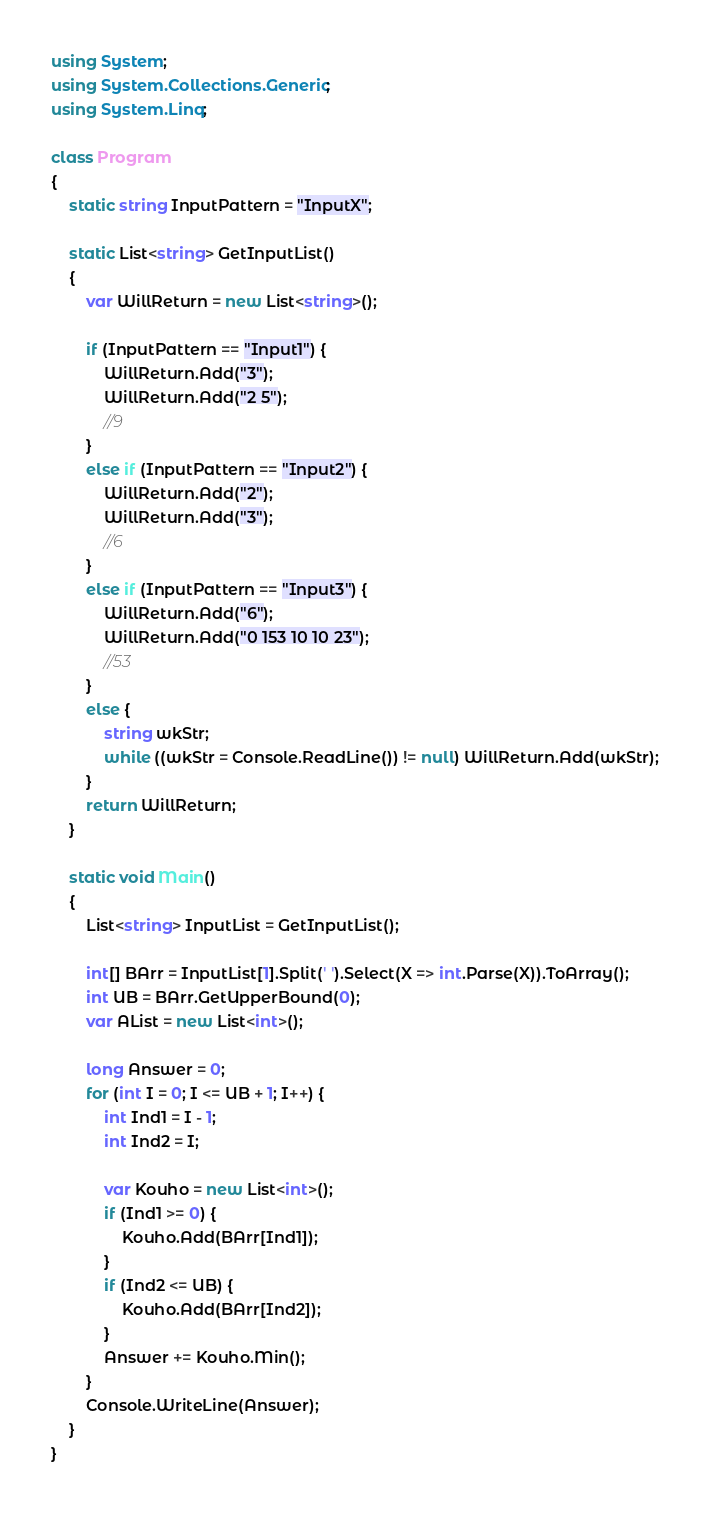Convert code to text. <code><loc_0><loc_0><loc_500><loc_500><_C#_>using System;
using System.Collections.Generic;
using System.Linq;

class Program
{
    static string InputPattern = "InputX";

    static List<string> GetInputList()
    {
        var WillReturn = new List<string>();

        if (InputPattern == "Input1") {
            WillReturn.Add("3");
            WillReturn.Add("2 5");
            //9
        }
        else if (InputPattern == "Input2") {
            WillReturn.Add("2");
            WillReturn.Add("3");
            //6
        }
        else if (InputPattern == "Input3") {
            WillReturn.Add("6");
            WillReturn.Add("0 153 10 10 23");
            //53
        }
        else {
            string wkStr;
            while ((wkStr = Console.ReadLine()) != null) WillReturn.Add(wkStr);
        }
        return WillReturn;
    }

    static void Main()
    {
        List<string> InputList = GetInputList();

        int[] BArr = InputList[1].Split(' ').Select(X => int.Parse(X)).ToArray();
        int UB = BArr.GetUpperBound(0);
        var AList = new List<int>();

        long Answer = 0;
        for (int I = 0; I <= UB + 1; I++) {
            int Ind1 = I - 1;
            int Ind2 = I;

            var Kouho = new List<int>();
            if (Ind1 >= 0) {
                Kouho.Add(BArr[Ind1]);
            }
            if (Ind2 <= UB) {
                Kouho.Add(BArr[Ind2]);
            }
            Answer += Kouho.Min();
        }
        Console.WriteLine(Answer);
    }
}
</code> 